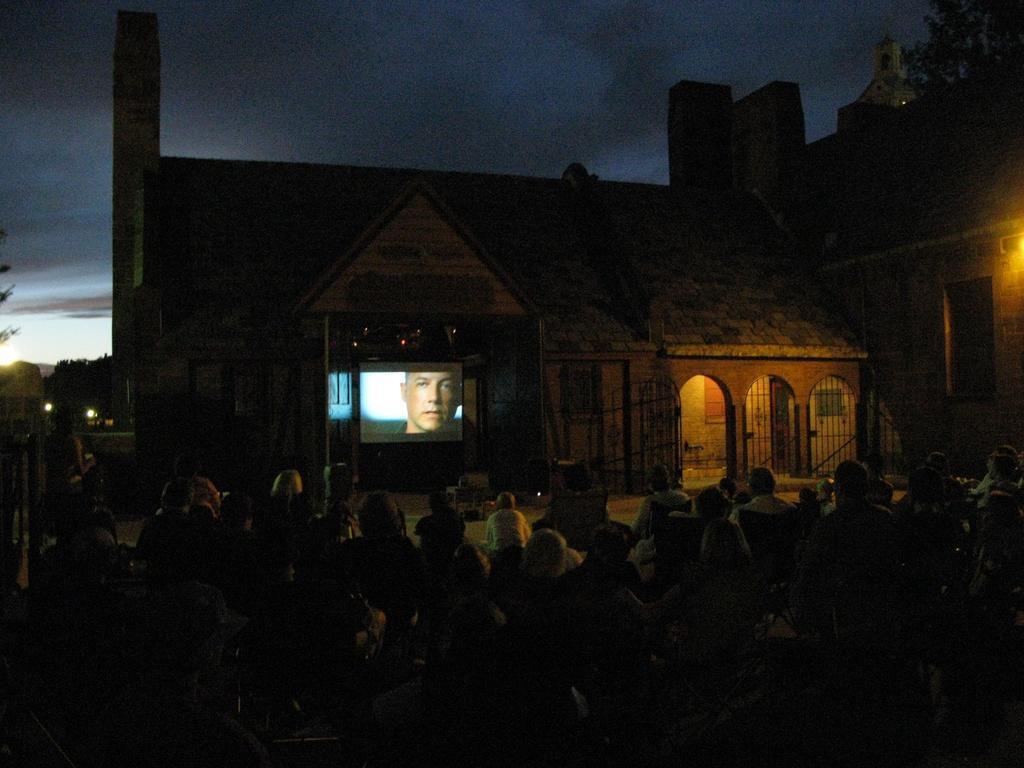How would you summarize this image in a sentence or two? On the bottom of the image we can see group of person sitting on the chair. Here we can see projector screen in that we can see a man. On the right we can see a building. On the top we can see sky and clouds. On the left we can see trees and light. 